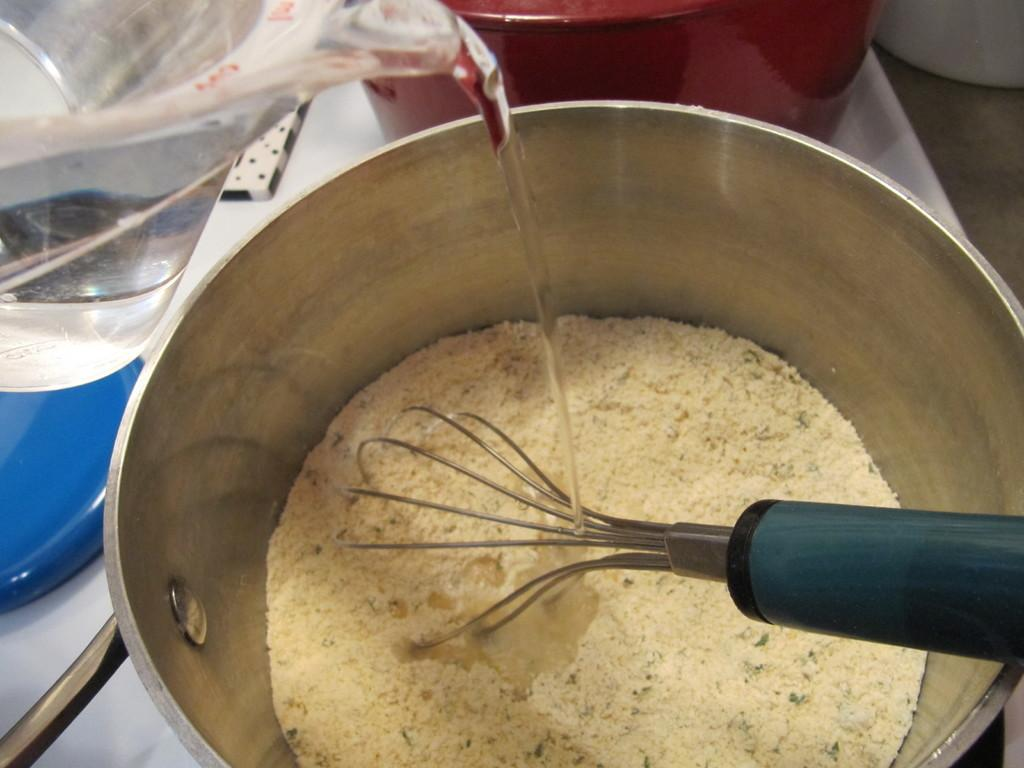What type of container is present in the image? There is a steel vessel in the image. What is inside the steel vessel? There is a powder in the steel vessel. What is used to mix the powder in the steel vessel? There is a stirrer in the steel vessel. What can be seen on the left side of the image? There is a water jug on the left side of the image. What is happening with the water from the jug? Water is flowing from the jug to the steel vessel. Can you see an airplane flying in the image? No, there is no airplane present in the image. 